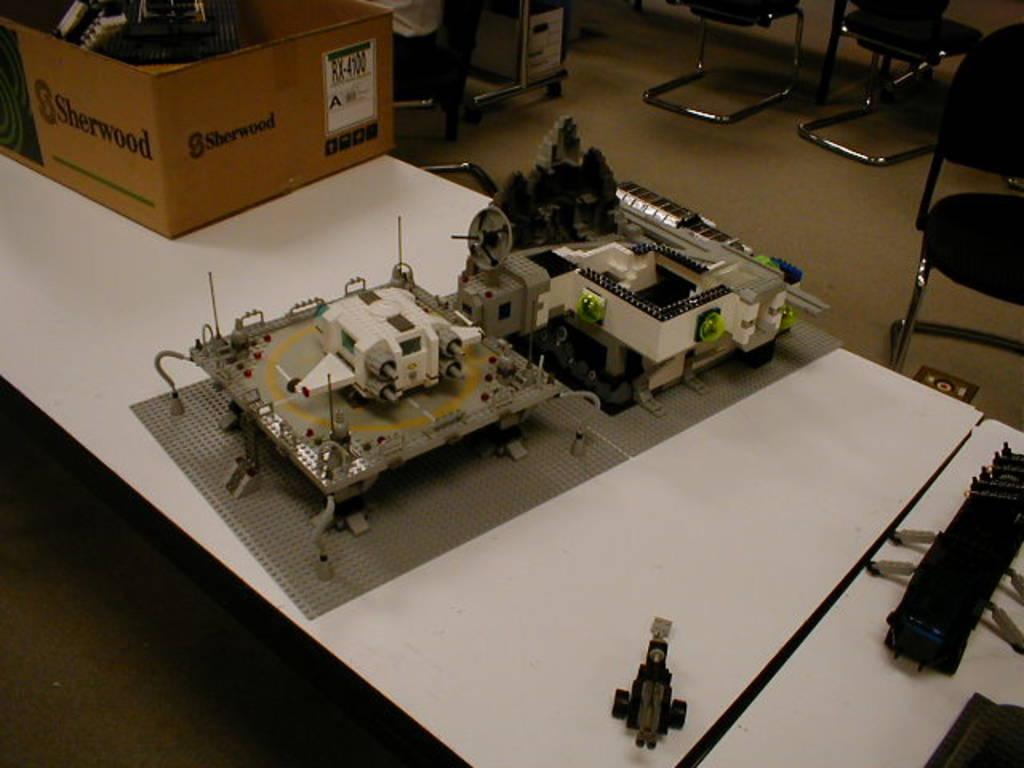Describe this image in one or two sentences. In this image there is a device kept on a table in middle of this image. there are some chairs at top right corner of this image and there is a box kept on a table at top left corner of this image. There is a table at bottom of this image is in white color. 